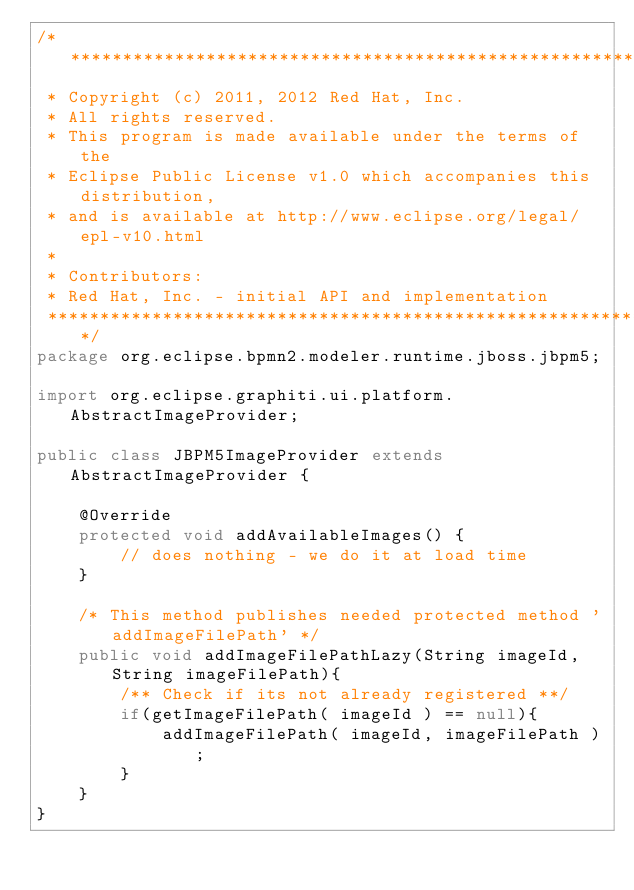<code> <loc_0><loc_0><loc_500><loc_500><_Java_>/*******************************************************************************
 * Copyright (c) 2011, 2012 Red Hat, Inc. 
 * All rights reserved. 
 * This program is made available under the terms of the 
 * Eclipse Public License v1.0 which accompanies this distribution, 
 * and is available at http://www.eclipse.org/legal/epl-v10.html 
 *
 * Contributors: 
 * Red Hat, Inc. - initial API and implementation 
 *******************************************************************************/
package org.eclipse.bpmn2.modeler.runtime.jboss.jbpm5;

import org.eclipse.graphiti.ui.platform.AbstractImageProvider;

public class JBPM5ImageProvider extends AbstractImageProvider {

	@Override
	protected void addAvailableImages() {
		// does nothing - we do it at load time
	}

	/* This method publishes needed protected method 'addImageFilePath' */
	public void addImageFilePathLazy(String imageId, String imageFilePath){
	    /** Check if its not already registered **/
	    if(getImageFilePath( imageId ) == null){
	        addImageFilePath( imageId, imageFilePath );
	    }
	}	
}
</code> 